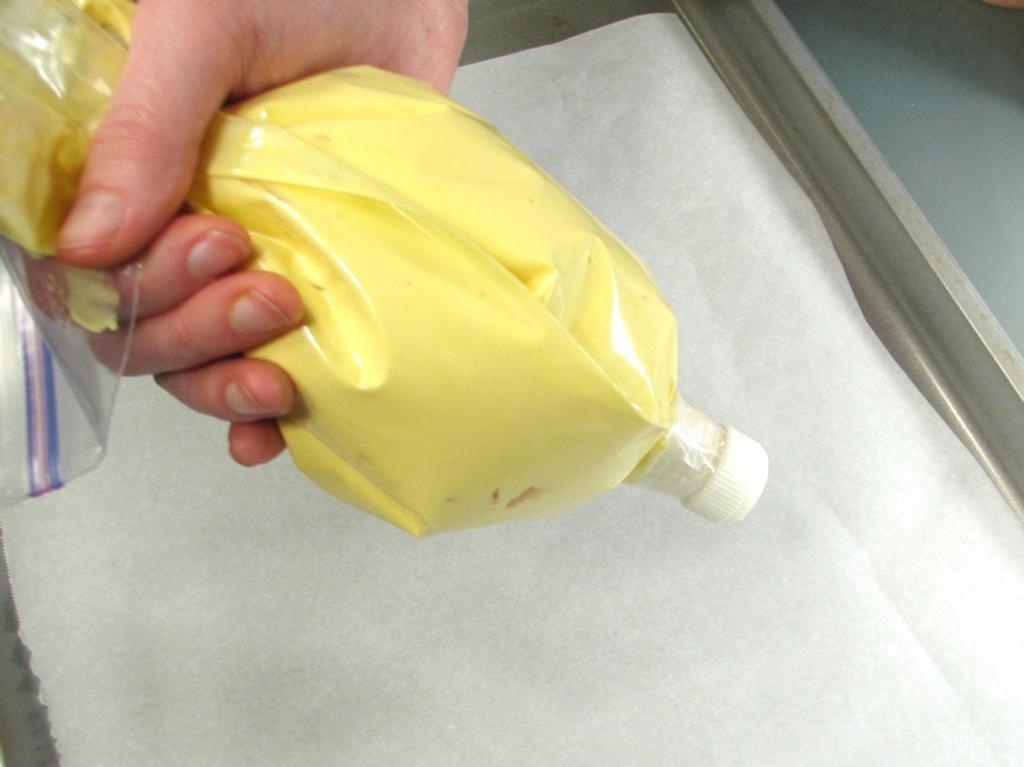Who or what is present in the image? There is a person in the image. What is the person holding in the image? The person is holding a bottle. What can be seen in the background of the image? There is a white color sheet and a window in the background of the image. What type of fuel is being used by the person in the image? There is no indication of any fuel being used in the image; the person is simply holding a bottle. 